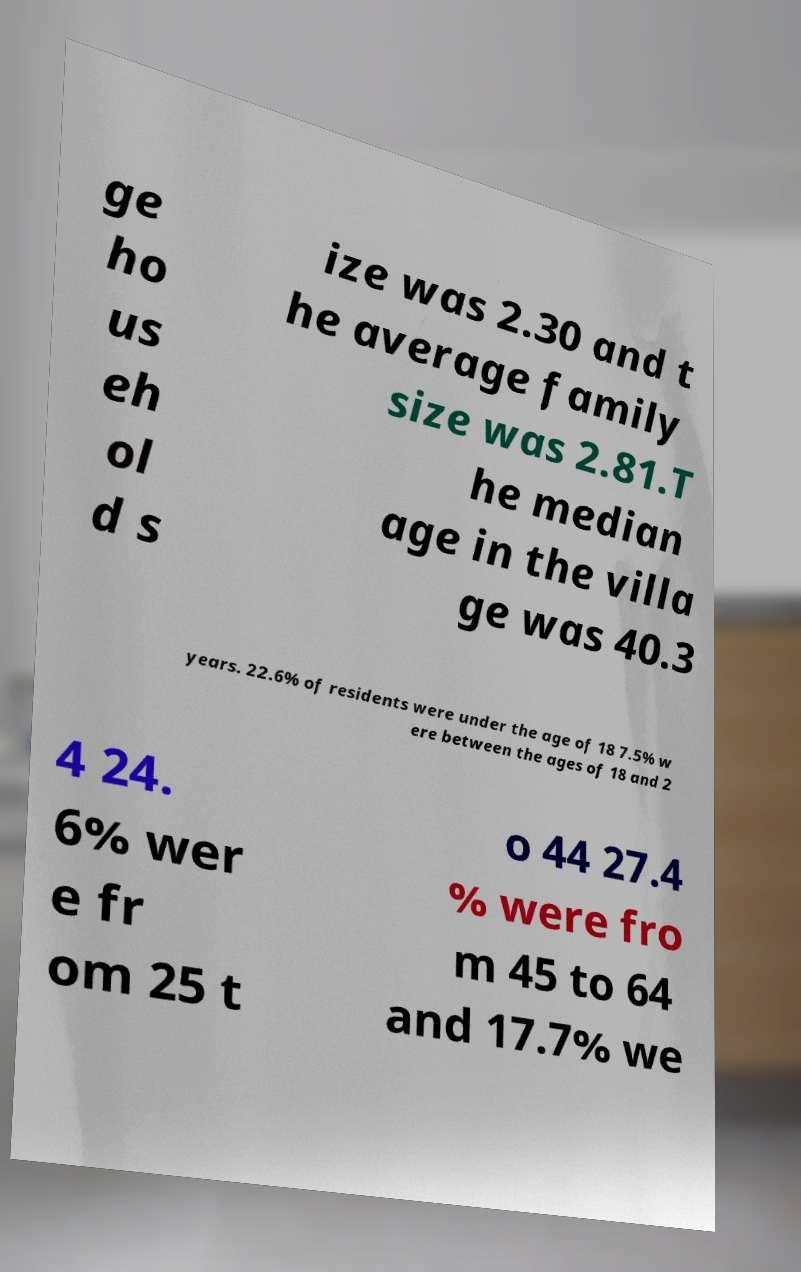Please identify and transcribe the text found in this image. ge ho us eh ol d s ize was 2.30 and t he average family size was 2.81.T he median age in the villa ge was 40.3 years. 22.6% of residents were under the age of 18 7.5% w ere between the ages of 18 and 2 4 24. 6% wer e fr om 25 t o 44 27.4 % were fro m 45 to 64 and 17.7% we 